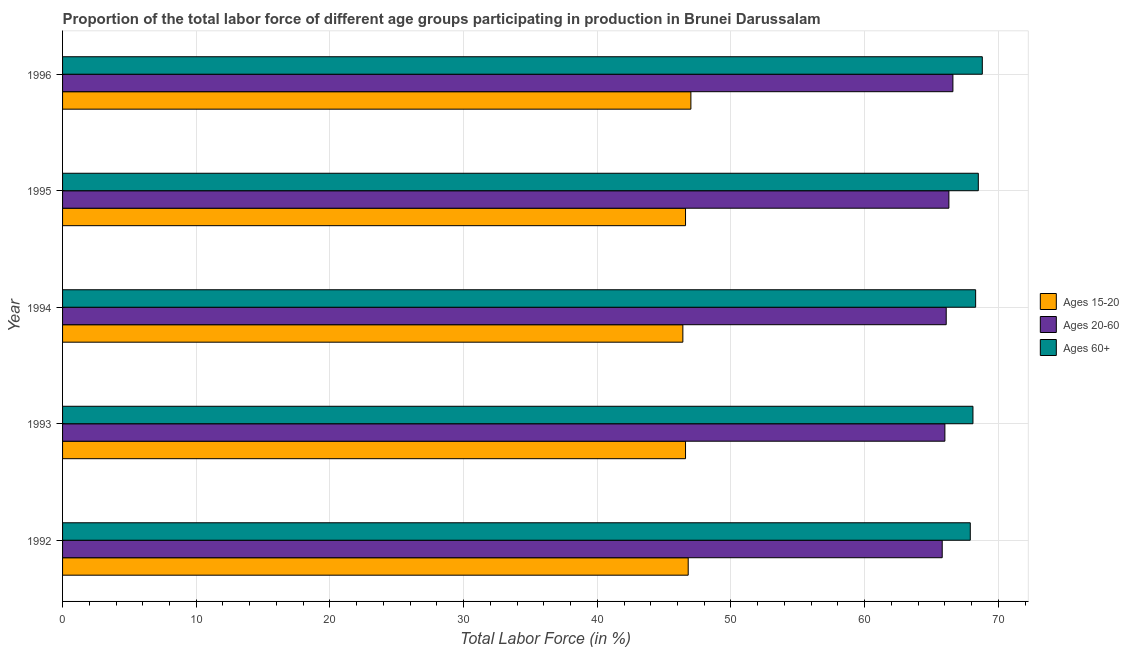How many different coloured bars are there?
Offer a very short reply. 3. How many bars are there on the 5th tick from the top?
Offer a very short reply. 3. How many bars are there on the 3rd tick from the bottom?
Provide a short and direct response. 3. What is the label of the 2nd group of bars from the top?
Your response must be concise. 1995. What is the percentage of labor force within the age group 20-60 in 1993?
Make the answer very short. 66. Across all years, what is the maximum percentage of labor force within the age group 20-60?
Keep it short and to the point. 66.6. Across all years, what is the minimum percentage of labor force within the age group 15-20?
Provide a short and direct response. 46.4. In which year was the percentage of labor force within the age group 15-20 maximum?
Provide a succinct answer. 1996. In which year was the percentage of labor force within the age group 15-20 minimum?
Ensure brevity in your answer.  1994. What is the total percentage of labor force within the age group 15-20 in the graph?
Offer a very short reply. 233.4. What is the difference between the percentage of labor force within the age group 15-20 in 1994 and that in 1996?
Your answer should be very brief. -0.6. What is the difference between the percentage of labor force within the age group 20-60 in 1992 and the percentage of labor force above age 60 in 1996?
Offer a very short reply. -3. What is the average percentage of labor force above age 60 per year?
Offer a very short reply. 68.32. In the year 1995, what is the difference between the percentage of labor force within the age group 20-60 and percentage of labor force above age 60?
Your answer should be compact. -2.2. What is the ratio of the percentage of labor force above age 60 in 1992 to that in 1995?
Your response must be concise. 0.99. Is the difference between the percentage of labor force above age 60 in 1994 and 1995 greater than the difference between the percentage of labor force within the age group 15-20 in 1994 and 1995?
Give a very brief answer. No. What does the 1st bar from the top in 1996 represents?
Provide a short and direct response. Ages 60+. What does the 3rd bar from the bottom in 1992 represents?
Your answer should be compact. Ages 60+. How many bars are there?
Offer a terse response. 15. Are all the bars in the graph horizontal?
Keep it short and to the point. Yes. What is the difference between two consecutive major ticks on the X-axis?
Your answer should be very brief. 10. How many legend labels are there?
Offer a terse response. 3. How are the legend labels stacked?
Keep it short and to the point. Vertical. What is the title of the graph?
Provide a short and direct response. Proportion of the total labor force of different age groups participating in production in Brunei Darussalam. Does "Errors" appear as one of the legend labels in the graph?
Offer a very short reply. No. What is the Total Labor Force (in %) in Ages 15-20 in 1992?
Your answer should be very brief. 46.8. What is the Total Labor Force (in %) of Ages 20-60 in 1992?
Offer a terse response. 65.8. What is the Total Labor Force (in %) in Ages 60+ in 1992?
Make the answer very short. 67.9. What is the Total Labor Force (in %) in Ages 15-20 in 1993?
Make the answer very short. 46.6. What is the Total Labor Force (in %) of Ages 60+ in 1993?
Provide a short and direct response. 68.1. What is the Total Labor Force (in %) in Ages 15-20 in 1994?
Make the answer very short. 46.4. What is the Total Labor Force (in %) of Ages 20-60 in 1994?
Your answer should be very brief. 66.1. What is the Total Labor Force (in %) in Ages 60+ in 1994?
Offer a terse response. 68.3. What is the Total Labor Force (in %) in Ages 15-20 in 1995?
Ensure brevity in your answer.  46.6. What is the Total Labor Force (in %) in Ages 20-60 in 1995?
Provide a succinct answer. 66.3. What is the Total Labor Force (in %) in Ages 60+ in 1995?
Your response must be concise. 68.5. What is the Total Labor Force (in %) of Ages 15-20 in 1996?
Provide a short and direct response. 47. What is the Total Labor Force (in %) of Ages 20-60 in 1996?
Make the answer very short. 66.6. What is the Total Labor Force (in %) in Ages 60+ in 1996?
Offer a very short reply. 68.8. Across all years, what is the maximum Total Labor Force (in %) in Ages 20-60?
Keep it short and to the point. 66.6. Across all years, what is the maximum Total Labor Force (in %) in Ages 60+?
Provide a succinct answer. 68.8. Across all years, what is the minimum Total Labor Force (in %) of Ages 15-20?
Provide a succinct answer. 46.4. Across all years, what is the minimum Total Labor Force (in %) in Ages 20-60?
Keep it short and to the point. 65.8. Across all years, what is the minimum Total Labor Force (in %) in Ages 60+?
Offer a very short reply. 67.9. What is the total Total Labor Force (in %) in Ages 15-20 in the graph?
Give a very brief answer. 233.4. What is the total Total Labor Force (in %) of Ages 20-60 in the graph?
Make the answer very short. 330.8. What is the total Total Labor Force (in %) in Ages 60+ in the graph?
Your answer should be very brief. 341.6. What is the difference between the Total Labor Force (in %) in Ages 15-20 in 1992 and that in 1993?
Keep it short and to the point. 0.2. What is the difference between the Total Labor Force (in %) of Ages 60+ in 1992 and that in 1993?
Offer a terse response. -0.2. What is the difference between the Total Labor Force (in %) in Ages 15-20 in 1992 and that in 1994?
Offer a very short reply. 0.4. What is the difference between the Total Labor Force (in %) in Ages 60+ in 1992 and that in 1994?
Your answer should be compact. -0.4. What is the difference between the Total Labor Force (in %) of Ages 60+ in 1992 and that in 1996?
Give a very brief answer. -0.9. What is the difference between the Total Labor Force (in %) in Ages 15-20 in 1993 and that in 1994?
Provide a short and direct response. 0.2. What is the difference between the Total Labor Force (in %) of Ages 20-60 in 1993 and that in 1994?
Ensure brevity in your answer.  -0.1. What is the difference between the Total Labor Force (in %) of Ages 60+ in 1993 and that in 1994?
Ensure brevity in your answer.  -0.2. What is the difference between the Total Labor Force (in %) in Ages 20-60 in 1993 and that in 1995?
Provide a succinct answer. -0.3. What is the difference between the Total Labor Force (in %) of Ages 60+ in 1993 and that in 1995?
Provide a short and direct response. -0.4. What is the difference between the Total Labor Force (in %) of Ages 20-60 in 1993 and that in 1996?
Provide a succinct answer. -0.6. What is the difference between the Total Labor Force (in %) in Ages 60+ in 1993 and that in 1996?
Your response must be concise. -0.7. What is the difference between the Total Labor Force (in %) in Ages 60+ in 1994 and that in 1995?
Your response must be concise. -0.2. What is the difference between the Total Labor Force (in %) in Ages 60+ in 1994 and that in 1996?
Make the answer very short. -0.5. What is the difference between the Total Labor Force (in %) of Ages 15-20 in 1995 and that in 1996?
Ensure brevity in your answer.  -0.4. What is the difference between the Total Labor Force (in %) of Ages 20-60 in 1995 and that in 1996?
Keep it short and to the point. -0.3. What is the difference between the Total Labor Force (in %) in Ages 15-20 in 1992 and the Total Labor Force (in %) in Ages 20-60 in 1993?
Offer a terse response. -19.2. What is the difference between the Total Labor Force (in %) in Ages 15-20 in 1992 and the Total Labor Force (in %) in Ages 60+ in 1993?
Keep it short and to the point. -21.3. What is the difference between the Total Labor Force (in %) of Ages 15-20 in 1992 and the Total Labor Force (in %) of Ages 20-60 in 1994?
Your answer should be very brief. -19.3. What is the difference between the Total Labor Force (in %) in Ages 15-20 in 1992 and the Total Labor Force (in %) in Ages 60+ in 1994?
Offer a terse response. -21.5. What is the difference between the Total Labor Force (in %) in Ages 15-20 in 1992 and the Total Labor Force (in %) in Ages 20-60 in 1995?
Your answer should be compact. -19.5. What is the difference between the Total Labor Force (in %) of Ages 15-20 in 1992 and the Total Labor Force (in %) of Ages 60+ in 1995?
Your answer should be compact. -21.7. What is the difference between the Total Labor Force (in %) of Ages 15-20 in 1992 and the Total Labor Force (in %) of Ages 20-60 in 1996?
Keep it short and to the point. -19.8. What is the difference between the Total Labor Force (in %) in Ages 15-20 in 1993 and the Total Labor Force (in %) in Ages 20-60 in 1994?
Offer a terse response. -19.5. What is the difference between the Total Labor Force (in %) in Ages 15-20 in 1993 and the Total Labor Force (in %) in Ages 60+ in 1994?
Offer a very short reply. -21.7. What is the difference between the Total Labor Force (in %) of Ages 15-20 in 1993 and the Total Labor Force (in %) of Ages 20-60 in 1995?
Your response must be concise. -19.7. What is the difference between the Total Labor Force (in %) in Ages 15-20 in 1993 and the Total Labor Force (in %) in Ages 60+ in 1995?
Ensure brevity in your answer.  -21.9. What is the difference between the Total Labor Force (in %) of Ages 15-20 in 1993 and the Total Labor Force (in %) of Ages 20-60 in 1996?
Keep it short and to the point. -20. What is the difference between the Total Labor Force (in %) of Ages 15-20 in 1993 and the Total Labor Force (in %) of Ages 60+ in 1996?
Your response must be concise. -22.2. What is the difference between the Total Labor Force (in %) of Ages 20-60 in 1993 and the Total Labor Force (in %) of Ages 60+ in 1996?
Your answer should be compact. -2.8. What is the difference between the Total Labor Force (in %) of Ages 15-20 in 1994 and the Total Labor Force (in %) of Ages 20-60 in 1995?
Your answer should be compact. -19.9. What is the difference between the Total Labor Force (in %) in Ages 15-20 in 1994 and the Total Labor Force (in %) in Ages 60+ in 1995?
Your answer should be very brief. -22.1. What is the difference between the Total Labor Force (in %) of Ages 15-20 in 1994 and the Total Labor Force (in %) of Ages 20-60 in 1996?
Provide a short and direct response. -20.2. What is the difference between the Total Labor Force (in %) in Ages 15-20 in 1994 and the Total Labor Force (in %) in Ages 60+ in 1996?
Offer a terse response. -22.4. What is the difference between the Total Labor Force (in %) in Ages 20-60 in 1994 and the Total Labor Force (in %) in Ages 60+ in 1996?
Provide a succinct answer. -2.7. What is the difference between the Total Labor Force (in %) in Ages 15-20 in 1995 and the Total Labor Force (in %) in Ages 60+ in 1996?
Give a very brief answer. -22.2. What is the average Total Labor Force (in %) of Ages 15-20 per year?
Ensure brevity in your answer.  46.68. What is the average Total Labor Force (in %) in Ages 20-60 per year?
Your answer should be very brief. 66.16. What is the average Total Labor Force (in %) of Ages 60+ per year?
Your answer should be very brief. 68.32. In the year 1992, what is the difference between the Total Labor Force (in %) of Ages 15-20 and Total Labor Force (in %) of Ages 60+?
Keep it short and to the point. -21.1. In the year 1993, what is the difference between the Total Labor Force (in %) in Ages 15-20 and Total Labor Force (in %) in Ages 20-60?
Your answer should be very brief. -19.4. In the year 1993, what is the difference between the Total Labor Force (in %) of Ages 15-20 and Total Labor Force (in %) of Ages 60+?
Ensure brevity in your answer.  -21.5. In the year 1993, what is the difference between the Total Labor Force (in %) of Ages 20-60 and Total Labor Force (in %) of Ages 60+?
Your answer should be compact. -2.1. In the year 1994, what is the difference between the Total Labor Force (in %) of Ages 15-20 and Total Labor Force (in %) of Ages 20-60?
Your answer should be compact. -19.7. In the year 1994, what is the difference between the Total Labor Force (in %) of Ages 15-20 and Total Labor Force (in %) of Ages 60+?
Ensure brevity in your answer.  -21.9. In the year 1994, what is the difference between the Total Labor Force (in %) in Ages 20-60 and Total Labor Force (in %) in Ages 60+?
Provide a succinct answer. -2.2. In the year 1995, what is the difference between the Total Labor Force (in %) of Ages 15-20 and Total Labor Force (in %) of Ages 20-60?
Offer a very short reply. -19.7. In the year 1995, what is the difference between the Total Labor Force (in %) of Ages 15-20 and Total Labor Force (in %) of Ages 60+?
Make the answer very short. -21.9. In the year 1995, what is the difference between the Total Labor Force (in %) in Ages 20-60 and Total Labor Force (in %) in Ages 60+?
Your answer should be very brief. -2.2. In the year 1996, what is the difference between the Total Labor Force (in %) in Ages 15-20 and Total Labor Force (in %) in Ages 20-60?
Ensure brevity in your answer.  -19.6. In the year 1996, what is the difference between the Total Labor Force (in %) in Ages 15-20 and Total Labor Force (in %) in Ages 60+?
Ensure brevity in your answer.  -21.8. In the year 1996, what is the difference between the Total Labor Force (in %) in Ages 20-60 and Total Labor Force (in %) in Ages 60+?
Your answer should be compact. -2.2. What is the ratio of the Total Labor Force (in %) in Ages 60+ in 1992 to that in 1993?
Make the answer very short. 1. What is the ratio of the Total Labor Force (in %) in Ages 15-20 in 1992 to that in 1994?
Your answer should be compact. 1.01. What is the ratio of the Total Labor Force (in %) of Ages 60+ in 1992 to that in 1994?
Provide a short and direct response. 0.99. What is the ratio of the Total Labor Force (in %) of Ages 20-60 in 1992 to that in 1995?
Keep it short and to the point. 0.99. What is the ratio of the Total Labor Force (in %) in Ages 60+ in 1992 to that in 1995?
Provide a succinct answer. 0.99. What is the ratio of the Total Labor Force (in %) of Ages 15-20 in 1992 to that in 1996?
Provide a short and direct response. 1. What is the ratio of the Total Labor Force (in %) in Ages 20-60 in 1992 to that in 1996?
Provide a short and direct response. 0.99. What is the ratio of the Total Labor Force (in %) of Ages 60+ in 1992 to that in 1996?
Provide a succinct answer. 0.99. What is the ratio of the Total Labor Force (in %) in Ages 15-20 in 1993 to that in 1994?
Provide a succinct answer. 1. What is the ratio of the Total Labor Force (in %) in Ages 60+ in 1993 to that in 1994?
Provide a short and direct response. 1. What is the ratio of the Total Labor Force (in %) of Ages 15-20 in 1993 to that in 1995?
Ensure brevity in your answer.  1. What is the ratio of the Total Labor Force (in %) in Ages 20-60 in 1993 to that in 1995?
Your answer should be very brief. 1. What is the ratio of the Total Labor Force (in %) in Ages 15-20 in 1993 to that in 1996?
Give a very brief answer. 0.99. What is the ratio of the Total Labor Force (in %) of Ages 60+ in 1993 to that in 1996?
Ensure brevity in your answer.  0.99. What is the ratio of the Total Labor Force (in %) in Ages 60+ in 1994 to that in 1995?
Keep it short and to the point. 1. What is the ratio of the Total Labor Force (in %) in Ages 15-20 in 1994 to that in 1996?
Keep it short and to the point. 0.99. What is the ratio of the Total Labor Force (in %) in Ages 20-60 in 1995 to that in 1996?
Offer a terse response. 1. What is the difference between the highest and the second highest Total Labor Force (in %) in Ages 15-20?
Provide a succinct answer. 0.2. What is the difference between the highest and the second highest Total Labor Force (in %) of Ages 60+?
Offer a terse response. 0.3. 